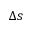<formula> <loc_0><loc_0><loc_500><loc_500>\Delta s</formula> 